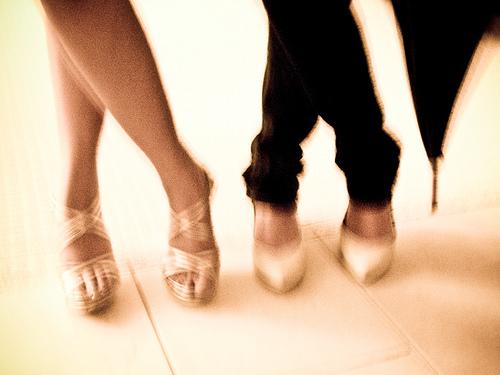Are these women walking with a natural gait?
Answer briefly. No. Is there an umbrella in the photo?
Be succinct. Yes. Are these women wearing dress shoes?
Answer briefly. Yes. 